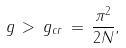<formula> <loc_0><loc_0><loc_500><loc_500>g \, > \, g _ { c r } \, = \, \frac { \pi ^ { 2 } } { 2 N } ,</formula> 